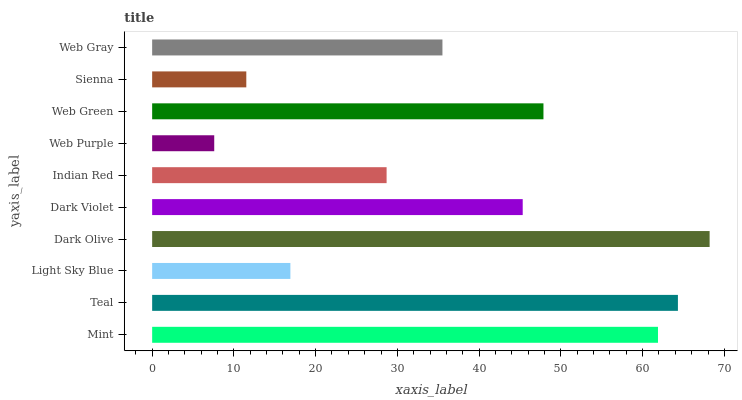Is Web Purple the minimum?
Answer yes or no. Yes. Is Dark Olive the maximum?
Answer yes or no. Yes. Is Teal the minimum?
Answer yes or no. No. Is Teal the maximum?
Answer yes or no. No. Is Teal greater than Mint?
Answer yes or no. Yes. Is Mint less than Teal?
Answer yes or no. Yes. Is Mint greater than Teal?
Answer yes or no. No. Is Teal less than Mint?
Answer yes or no. No. Is Dark Violet the high median?
Answer yes or no. Yes. Is Web Gray the low median?
Answer yes or no. Yes. Is Sienna the high median?
Answer yes or no. No. Is Web Purple the low median?
Answer yes or no. No. 